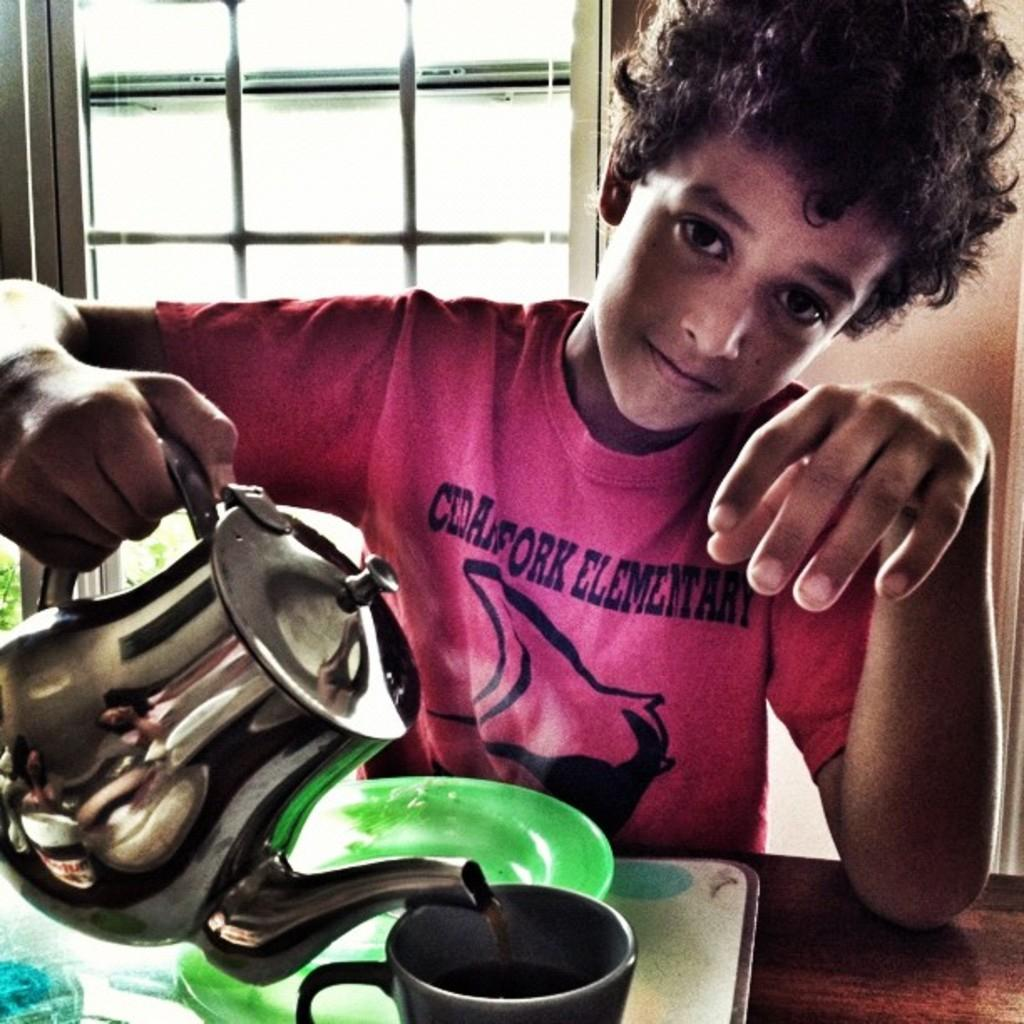Who is the main subject in the image? There is a boy in the image. What is the boy holding in the image? The boy is holding a jug in the image. What is in front of the boy? There is a wooden surface in front of the boy. What is on the wooden surface? There is a tray on the wooden surface, and it contains a plate and a cup. What can be seen in the background of the image? There is a wall with a window in the background. What time is the actor performing in the image? There is no actor present in the image, and therefore no performance can be observed. 